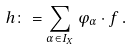Convert formula to latex. <formula><loc_0><loc_0><loc_500><loc_500>h \colon = \sum _ { \alpha \in I _ { X } } \varphi _ { \alpha } \cdot f \, .</formula> 